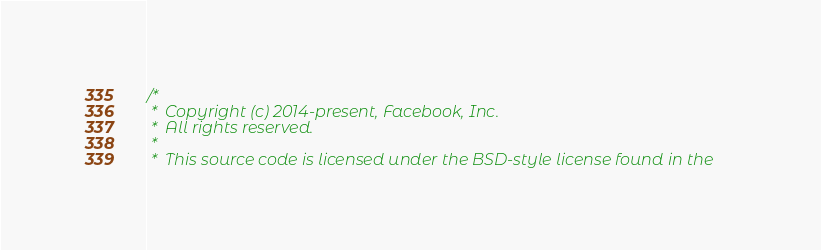Convert code to text. <code><loc_0><loc_0><loc_500><loc_500><_ObjectiveC_>/*
 *  Copyright (c) 2014-present, Facebook, Inc.
 *  All rights reserved.
 *
 *  This source code is licensed under the BSD-style license found in the</code> 